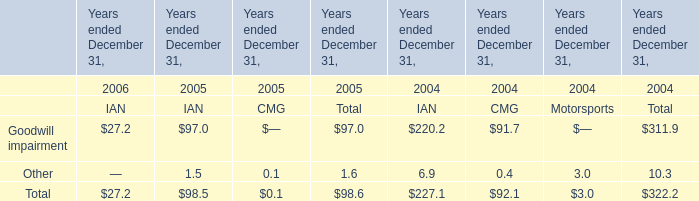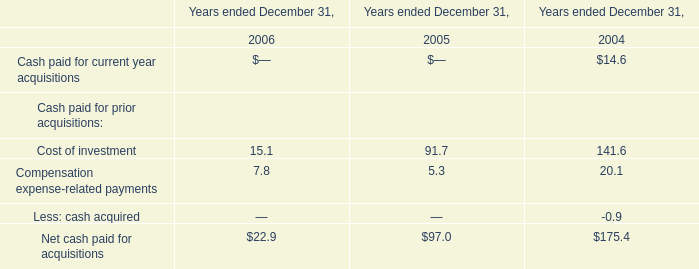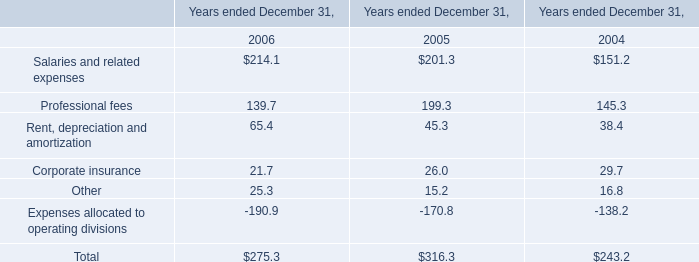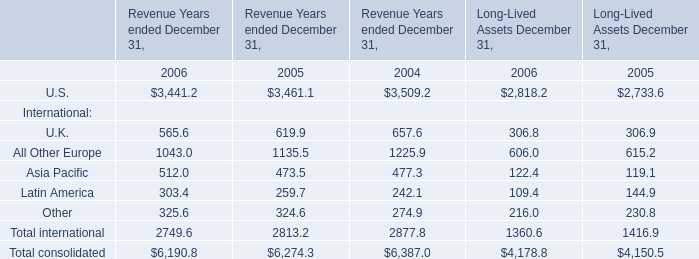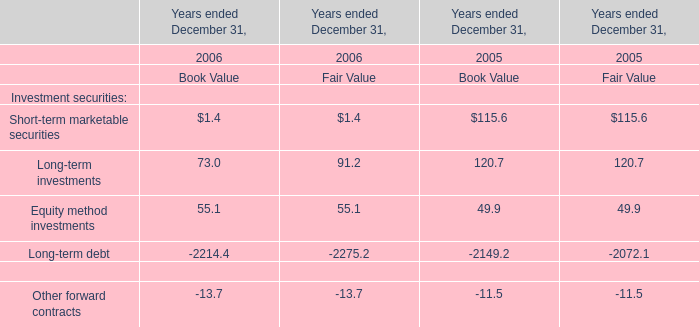What will U.K. for Revenue Years ended December 31 be like in 2007 if it develops with the same increasing rate as current? 
Computations: (565.6 * (1 + ((565.6 - 619.9) / 619.9)))
Answer: 516.0564. 